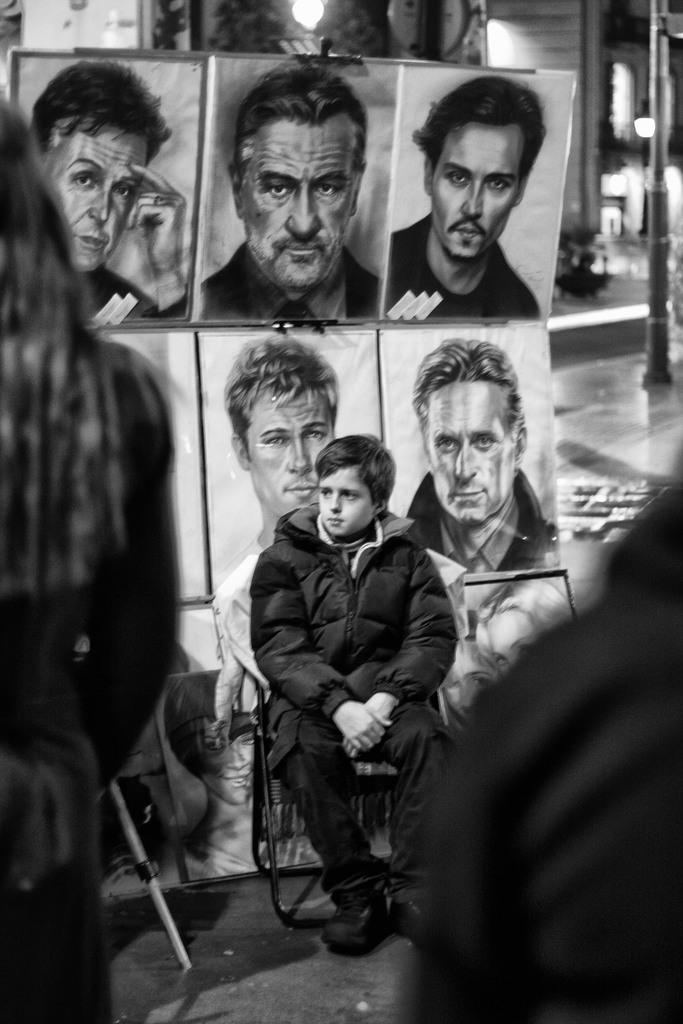What is the primary subject in the image? There is a person sitting in the image. Can you describe the background of the image? There are faces of other people visible in the background, and there are lights in the background as well. What is the color scheme of the image? The image is in black and white. How many girls are performing a kick in the image? There are no girls or kicks present in the image. 